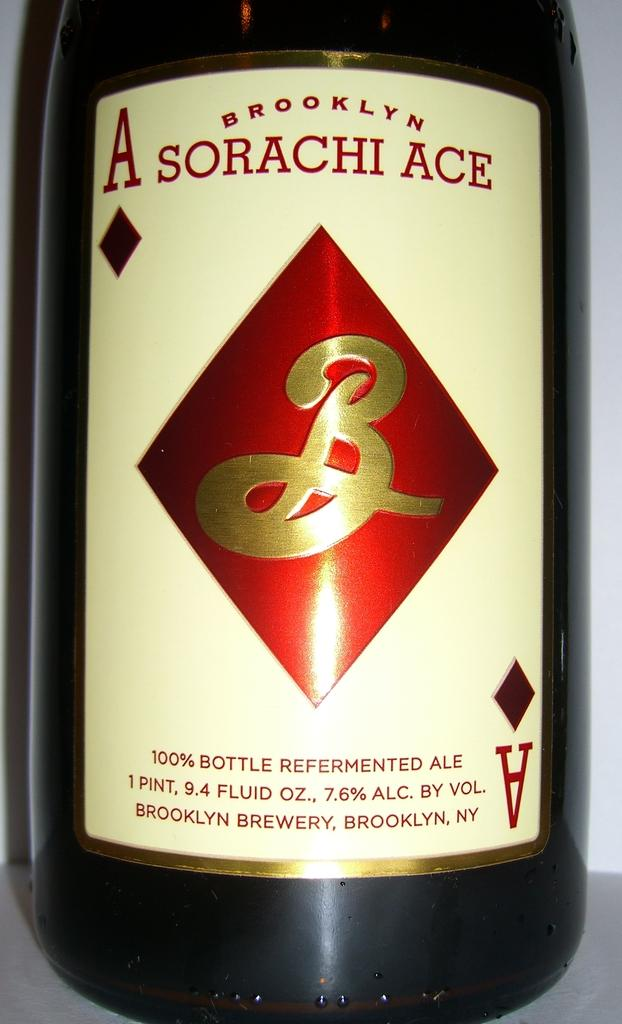<image>
Write a terse but informative summary of the picture. A bottle of ale is 9.4 fluid ounces and has a red and gold logo. 